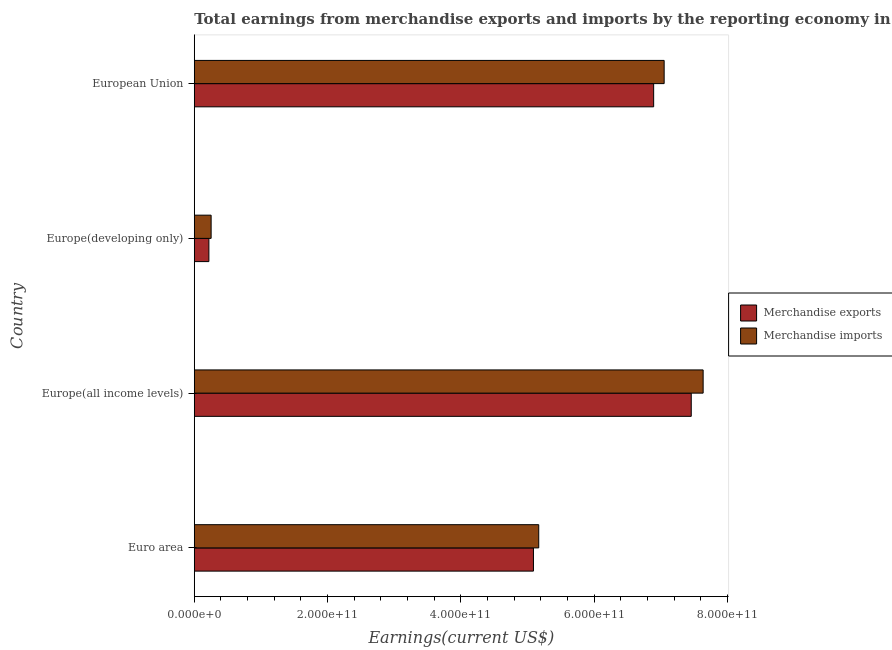How many groups of bars are there?
Your answer should be very brief. 4. How many bars are there on the 2nd tick from the top?
Give a very brief answer. 2. What is the earnings from merchandise imports in Europe(developing only)?
Provide a short and direct response. 2.53e+1. Across all countries, what is the maximum earnings from merchandise imports?
Give a very brief answer. 7.63e+11. Across all countries, what is the minimum earnings from merchandise imports?
Provide a short and direct response. 2.53e+1. In which country was the earnings from merchandise exports maximum?
Your answer should be compact. Europe(all income levels). In which country was the earnings from merchandise exports minimum?
Give a very brief answer. Europe(developing only). What is the total earnings from merchandise exports in the graph?
Offer a very short reply. 1.97e+12. What is the difference between the earnings from merchandise imports in Europe(all income levels) and that in European Union?
Ensure brevity in your answer.  5.85e+1. What is the difference between the earnings from merchandise exports in Europe(developing only) and the earnings from merchandise imports in Europe(all income levels)?
Your answer should be compact. -7.42e+11. What is the average earnings from merchandise exports per country?
Your answer should be very brief. 4.91e+11. What is the difference between the earnings from merchandise imports and earnings from merchandise exports in Euro area?
Your answer should be compact. 7.91e+09. What is the ratio of the earnings from merchandise exports in Euro area to that in Europe(developing only)?
Your answer should be very brief. 23.2. Is the earnings from merchandise imports in Europe(developing only) less than that in European Union?
Keep it short and to the point. Yes. Is the difference between the earnings from merchandise exports in Euro area and European Union greater than the difference between the earnings from merchandise imports in Euro area and European Union?
Keep it short and to the point. Yes. What is the difference between the highest and the second highest earnings from merchandise exports?
Give a very brief answer. 5.64e+1. What is the difference between the highest and the lowest earnings from merchandise imports?
Offer a very short reply. 7.38e+11. What does the 2nd bar from the top in Europe(developing only) represents?
Offer a terse response. Merchandise exports. How many bars are there?
Offer a very short reply. 8. Are all the bars in the graph horizontal?
Your answer should be very brief. Yes. What is the difference between two consecutive major ticks on the X-axis?
Your response must be concise. 2.00e+11. Does the graph contain any zero values?
Give a very brief answer. No. Does the graph contain grids?
Your answer should be compact. No. How are the legend labels stacked?
Keep it short and to the point. Vertical. What is the title of the graph?
Your response must be concise. Total earnings from merchandise exports and imports by the reporting economy in 1985. What is the label or title of the X-axis?
Your answer should be compact. Earnings(current US$). What is the Earnings(current US$) in Merchandise exports in Euro area?
Make the answer very short. 5.09e+11. What is the Earnings(current US$) in Merchandise imports in Euro area?
Offer a terse response. 5.17e+11. What is the Earnings(current US$) in Merchandise exports in Europe(all income levels)?
Provide a succinct answer. 7.46e+11. What is the Earnings(current US$) of Merchandise imports in Europe(all income levels)?
Offer a terse response. 7.63e+11. What is the Earnings(current US$) of Merchandise exports in Europe(developing only)?
Offer a terse response. 2.19e+1. What is the Earnings(current US$) in Merchandise imports in Europe(developing only)?
Make the answer very short. 2.53e+1. What is the Earnings(current US$) of Merchandise exports in European Union?
Offer a very short reply. 6.89e+11. What is the Earnings(current US$) of Merchandise imports in European Union?
Ensure brevity in your answer.  7.05e+11. Across all countries, what is the maximum Earnings(current US$) of Merchandise exports?
Ensure brevity in your answer.  7.46e+11. Across all countries, what is the maximum Earnings(current US$) of Merchandise imports?
Provide a succinct answer. 7.63e+11. Across all countries, what is the minimum Earnings(current US$) of Merchandise exports?
Your answer should be very brief. 2.19e+1. Across all countries, what is the minimum Earnings(current US$) of Merchandise imports?
Offer a very short reply. 2.53e+1. What is the total Earnings(current US$) in Merchandise exports in the graph?
Ensure brevity in your answer.  1.97e+12. What is the total Earnings(current US$) of Merchandise imports in the graph?
Your answer should be compact. 2.01e+12. What is the difference between the Earnings(current US$) of Merchandise exports in Euro area and that in Europe(all income levels)?
Offer a terse response. -2.37e+11. What is the difference between the Earnings(current US$) of Merchandise imports in Euro area and that in Europe(all income levels)?
Provide a succinct answer. -2.47e+11. What is the difference between the Earnings(current US$) in Merchandise exports in Euro area and that in Europe(developing only)?
Offer a very short reply. 4.87e+11. What is the difference between the Earnings(current US$) in Merchandise imports in Euro area and that in Europe(developing only)?
Make the answer very short. 4.91e+11. What is the difference between the Earnings(current US$) in Merchandise exports in Euro area and that in European Union?
Keep it short and to the point. -1.80e+11. What is the difference between the Earnings(current US$) in Merchandise imports in Euro area and that in European Union?
Your answer should be very brief. -1.88e+11. What is the difference between the Earnings(current US$) of Merchandise exports in Europe(all income levels) and that in Europe(developing only)?
Provide a succinct answer. 7.24e+11. What is the difference between the Earnings(current US$) of Merchandise imports in Europe(all income levels) and that in Europe(developing only)?
Give a very brief answer. 7.38e+11. What is the difference between the Earnings(current US$) in Merchandise exports in Europe(all income levels) and that in European Union?
Give a very brief answer. 5.64e+1. What is the difference between the Earnings(current US$) of Merchandise imports in Europe(all income levels) and that in European Union?
Make the answer very short. 5.85e+1. What is the difference between the Earnings(current US$) in Merchandise exports in Europe(developing only) and that in European Union?
Offer a very short reply. -6.67e+11. What is the difference between the Earnings(current US$) in Merchandise imports in Europe(developing only) and that in European Union?
Keep it short and to the point. -6.80e+11. What is the difference between the Earnings(current US$) in Merchandise exports in Euro area and the Earnings(current US$) in Merchandise imports in Europe(all income levels)?
Your answer should be compact. -2.55e+11. What is the difference between the Earnings(current US$) in Merchandise exports in Euro area and the Earnings(current US$) in Merchandise imports in Europe(developing only)?
Offer a very short reply. 4.84e+11. What is the difference between the Earnings(current US$) of Merchandise exports in Euro area and the Earnings(current US$) of Merchandise imports in European Union?
Provide a short and direct response. -1.96e+11. What is the difference between the Earnings(current US$) of Merchandise exports in Europe(all income levels) and the Earnings(current US$) of Merchandise imports in Europe(developing only)?
Offer a terse response. 7.20e+11. What is the difference between the Earnings(current US$) in Merchandise exports in Europe(all income levels) and the Earnings(current US$) in Merchandise imports in European Union?
Your answer should be very brief. 4.07e+1. What is the difference between the Earnings(current US$) in Merchandise exports in Europe(developing only) and the Earnings(current US$) in Merchandise imports in European Union?
Your answer should be very brief. -6.83e+11. What is the average Earnings(current US$) of Merchandise exports per country?
Keep it short and to the point. 4.91e+11. What is the average Earnings(current US$) in Merchandise imports per country?
Your answer should be compact. 5.03e+11. What is the difference between the Earnings(current US$) in Merchandise exports and Earnings(current US$) in Merchandise imports in Euro area?
Your answer should be compact. -7.91e+09. What is the difference between the Earnings(current US$) of Merchandise exports and Earnings(current US$) of Merchandise imports in Europe(all income levels)?
Your answer should be very brief. -1.78e+1. What is the difference between the Earnings(current US$) of Merchandise exports and Earnings(current US$) of Merchandise imports in Europe(developing only)?
Keep it short and to the point. -3.36e+09. What is the difference between the Earnings(current US$) in Merchandise exports and Earnings(current US$) in Merchandise imports in European Union?
Offer a terse response. -1.58e+1. What is the ratio of the Earnings(current US$) of Merchandise exports in Euro area to that in Europe(all income levels)?
Ensure brevity in your answer.  0.68. What is the ratio of the Earnings(current US$) of Merchandise imports in Euro area to that in Europe(all income levels)?
Offer a terse response. 0.68. What is the ratio of the Earnings(current US$) in Merchandise exports in Euro area to that in Europe(developing only)?
Your answer should be very brief. 23.2. What is the ratio of the Earnings(current US$) of Merchandise imports in Euro area to that in Europe(developing only)?
Provide a succinct answer. 20.43. What is the ratio of the Earnings(current US$) in Merchandise exports in Euro area to that in European Union?
Your answer should be compact. 0.74. What is the ratio of the Earnings(current US$) in Merchandise imports in Euro area to that in European Union?
Provide a succinct answer. 0.73. What is the ratio of the Earnings(current US$) in Merchandise exports in Europe(all income levels) to that in Europe(developing only)?
Give a very brief answer. 33.99. What is the ratio of the Earnings(current US$) of Merchandise imports in Europe(all income levels) to that in Europe(developing only)?
Offer a terse response. 30.18. What is the ratio of the Earnings(current US$) of Merchandise exports in Europe(all income levels) to that in European Union?
Provide a short and direct response. 1.08. What is the ratio of the Earnings(current US$) of Merchandise imports in Europe(all income levels) to that in European Union?
Your answer should be compact. 1.08. What is the ratio of the Earnings(current US$) of Merchandise exports in Europe(developing only) to that in European Union?
Your answer should be compact. 0.03. What is the ratio of the Earnings(current US$) of Merchandise imports in Europe(developing only) to that in European Union?
Your answer should be very brief. 0.04. What is the difference between the highest and the second highest Earnings(current US$) of Merchandise exports?
Keep it short and to the point. 5.64e+1. What is the difference between the highest and the second highest Earnings(current US$) of Merchandise imports?
Your answer should be very brief. 5.85e+1. What is the difference between the highest and the lowest Earnings(current US$) in Merchandise exports?
Your response must be concise. 7.24e+11. What is the difference between the highest and the lowest Earnings(current US$) in Merchandise imports?
Make the answer very short. 7.38e+11. 